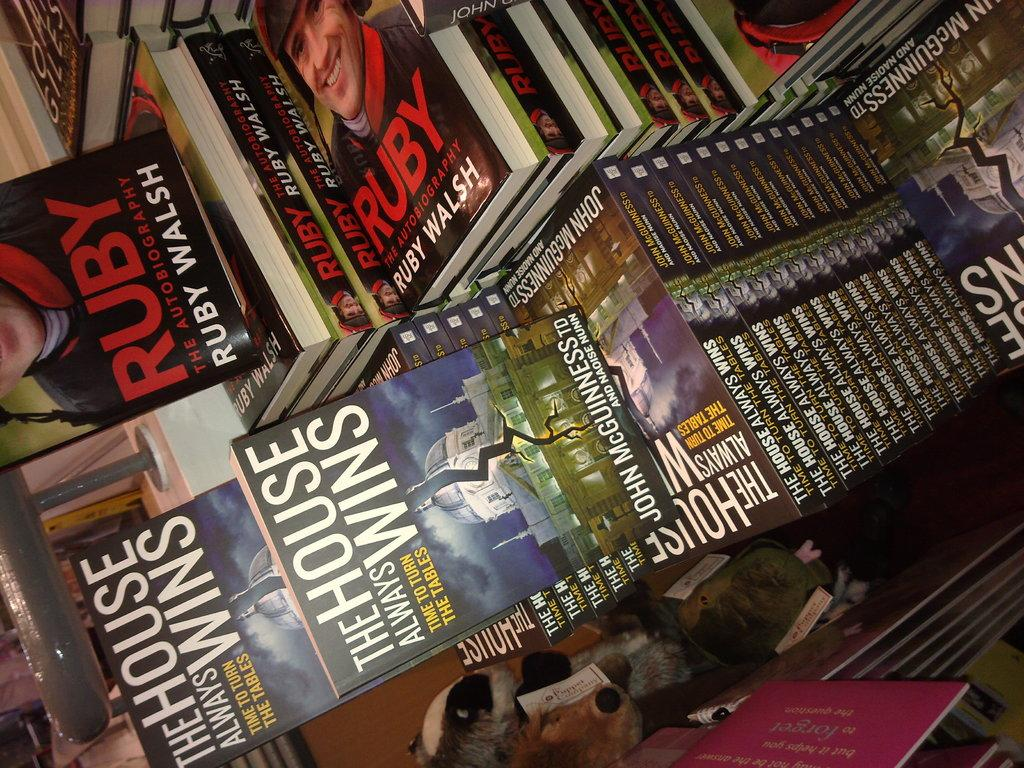<image>
Describe the image concisely. One of the books on display is the autobiography of Ruby Walsh titled Ruby. 